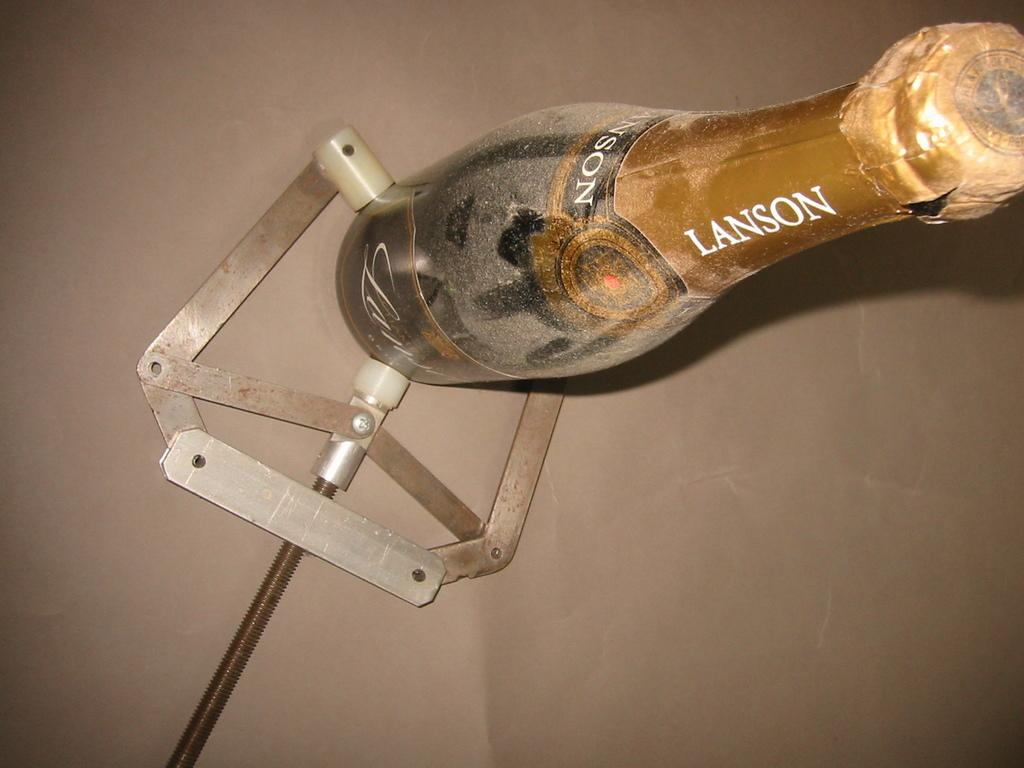<image>
Give a short and clear explanation of the subsequent image. A bottle has the brand name Lanson on it and is unopened. 